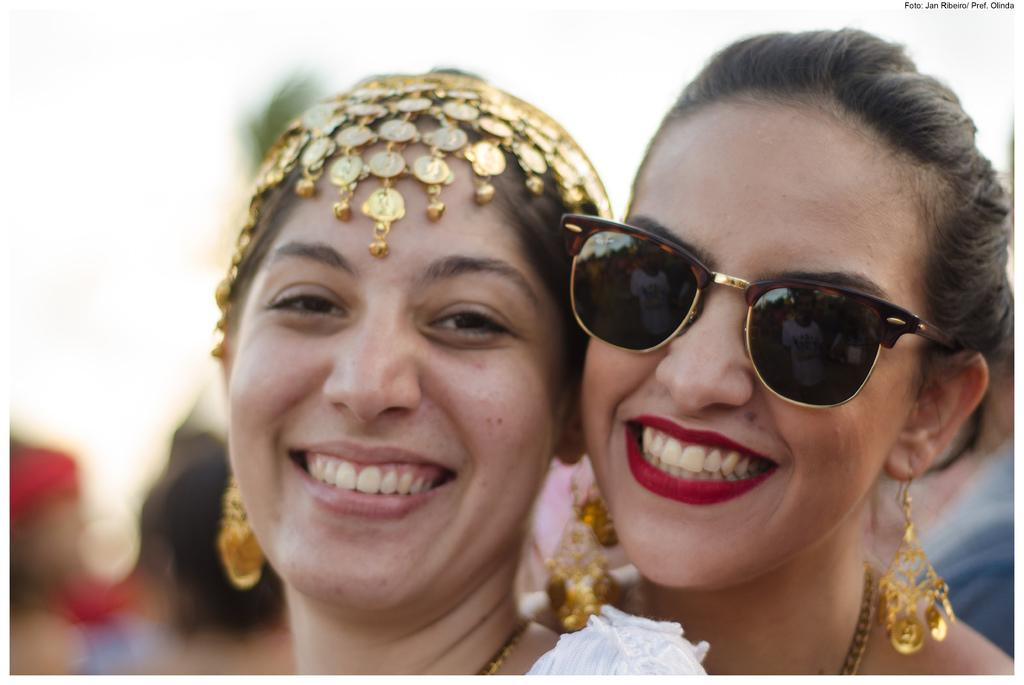How many people are in the image? There are two women in the image. What are the women wearing? The women are wearing clothes, neck chains, earrings, and head ware. Can you describe the accessories worn by the women? One woman is wearing goggles, and both women are wearing neck chains and earrings. What is the condition of the background in the image? The background of the image is blurred. Is there any text or marking visible in the image? Yes, there is a watermark in the image. What type of watch can be seen on the wrist of the woman in the image? There is no watch visible on the wrist of the woman in the image. Can you hear the bells ringing in the image? There are no bells present in the image, so it is not possible to hear them ringing. 